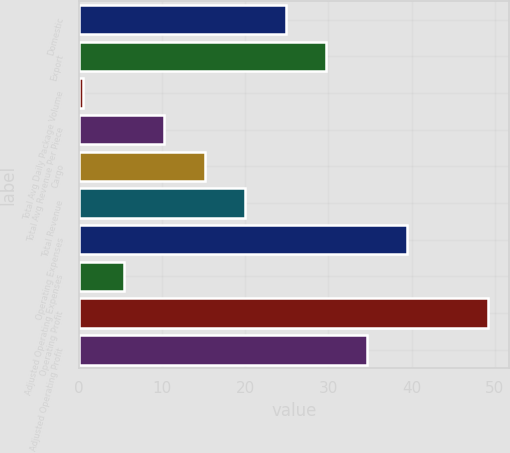Convert chart to OTSL. <chart><loc_0><loc_0><loc_500><loc_500><bar_chart><fcel>Domestic<fcel>Export<fcel>Total Avg Daily Package Volume<fcel>Total Avg Revenue Per Piece<fcel>Cargo<fcel>Total Revenue<fcel>Operating Expenses<fcel>Adjusted Operating Expenses<fcel>Operating Profit<fcel>Adjusted Operating Profit<nl><fcel>24.85<fcel>29.72<fcel>0.5<fcel>10.24<fcel>15.11<fcel>19.98<fcel>39.46<fcel>5.37<fcel>49.2<fcel>34.59<nl></chart> 